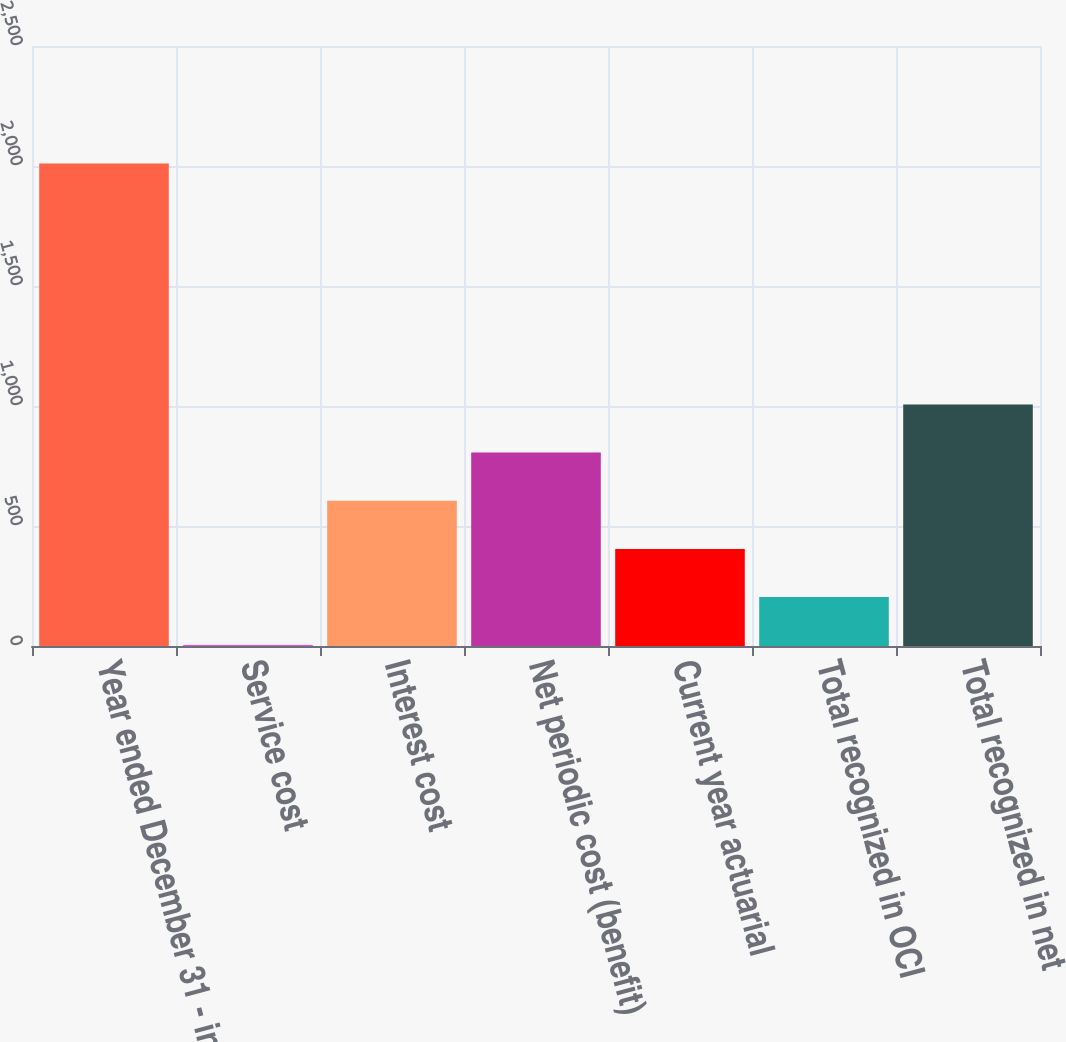<chart> <loc_0><loc_0><loc_500><loc_500><bar_chart><fcel>Year ended December 31 - in<fcel>Service cost<fcel>Interest cost<fcel>Net periodic cost (benefit)<fcel>Current year actuarial<fcel>Total recognized in OCI<fcel>Total recognized in net<nl><fcel>2010<fcel>3<fcel>605.1<fcel>805.8<fcel>404.4<fcel>203.7<fcel>1006.5<nl></chart> 